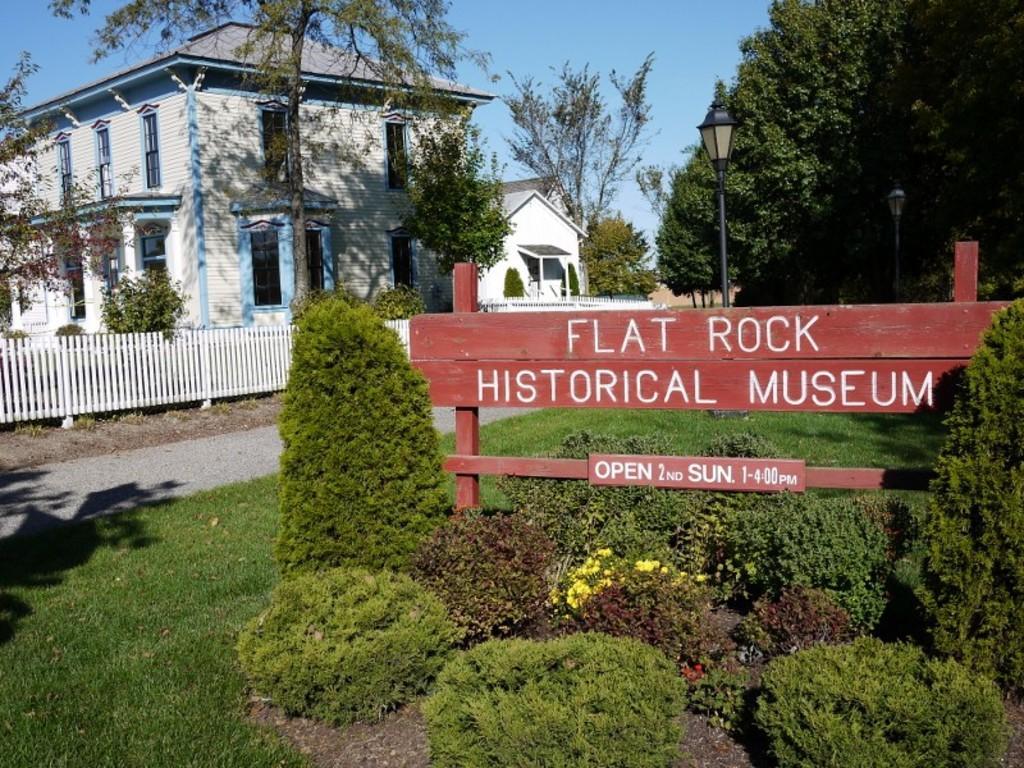Describe this image in one or two sentences. In this image there is a building with trees and wooden fence, in front of the building there is a wooden structure with some text is on the surface of the grass, around that there are trees and plants. In the background there is the sky. 